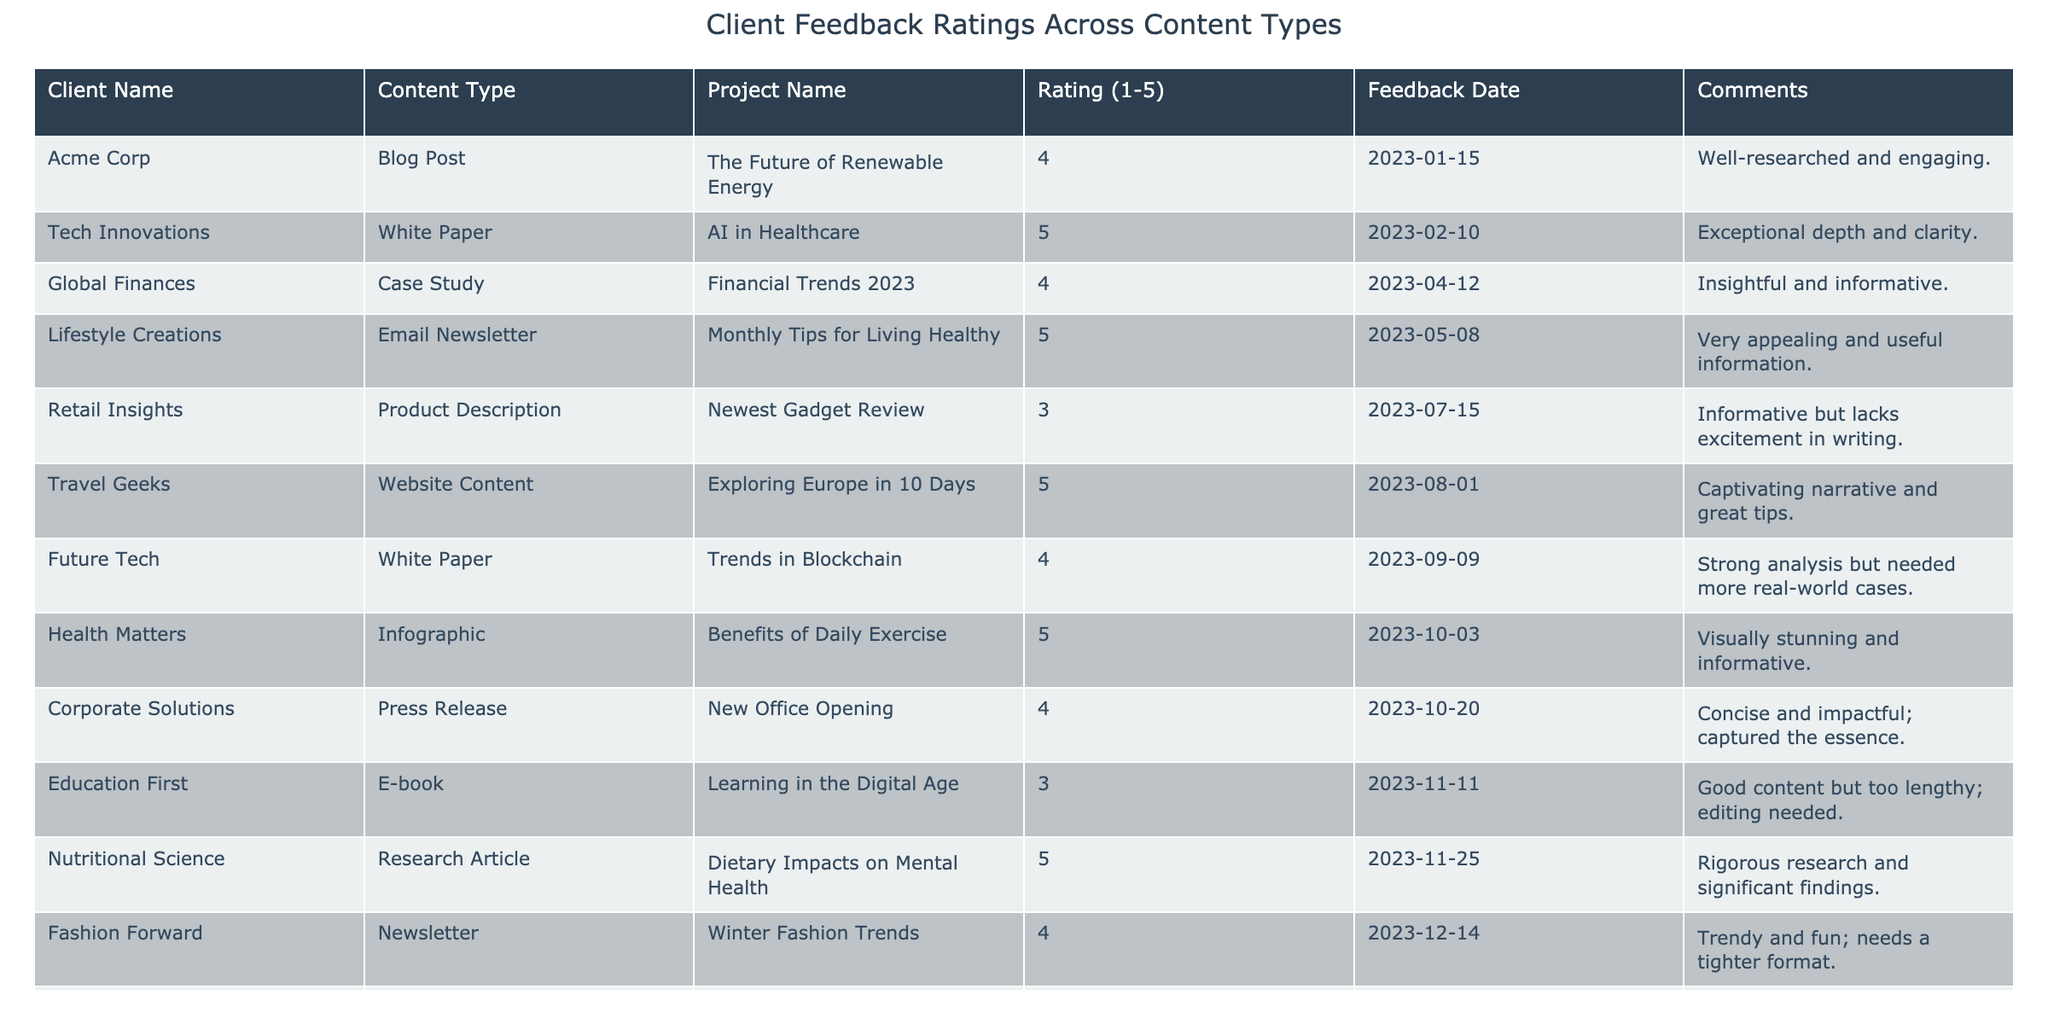What is the highest rating received by a project? The maximum rating in the table is 5. Looking at the "Rating (1-5)" column, multiple entries have this highest rating.
Answer: 5 Which content type received the least favorable rating? The content type with the lowest rating is "Product Description," which received a rating of 3. I checked all ratings, and this was the lowest.
Answer: Product Description How many projects received a rating of 4 or higher? There are 7 ratings of 4 or higher in the table. By counting the ratings, I found seven instances of 4 and 5 ratings combined.
Answer: 7 What is the average rating of all the projects listed? The average is calculated by summing all the ratings (4 + 5 + 4 + 5 + 3 + 5 + 4 + 5 + 4 + 3 + 5 + 4 + 5) = 53 and dividing by the number of projects (13). Thus, 53/13 = 4.08.
Answer: 4.08 Did "Health Matters" receive a higher rating than "Educational First"? "Health Matters" received a rating of 5, while "Educational First" received a rating of 3. Since 5 is greater than 3, the answer is yes.
Answer: Yes Which project received feedback on the most recent date? The most recent feedback date is 2023-12-29 from "Local Eats." I checked all feedback dates and found this to be the latest.
Answer: Local Eats What content type had the most entries in the table? By scanning the "Content Type" column, "White Paper" appears twice, while others mostly appear once or twice. Therefore, it ties with some other types, but has a prominent count.
Answer: White Paper How many content types received a rating of 5? There are 5 instances of projects that received a rating of 5 as I reviewed the ratings closely and counted these individual entries.
Answer: 5 Is there any case study listed in the feedback? Yes, "Financial Trends 2023" is listed as a case study, with a rating of 4. I looked through the "Content Type" column to find this category.
Answer: Yes What do the comments for the highest-rated content types indicate? The comments for the ratings of 5 generally express satisfaction, describing them as "exceptional," "visually stunning," and "delicious." I summarized several comments from those rated 5 to reach this conclusion.
Answer: Positive satisfaction 